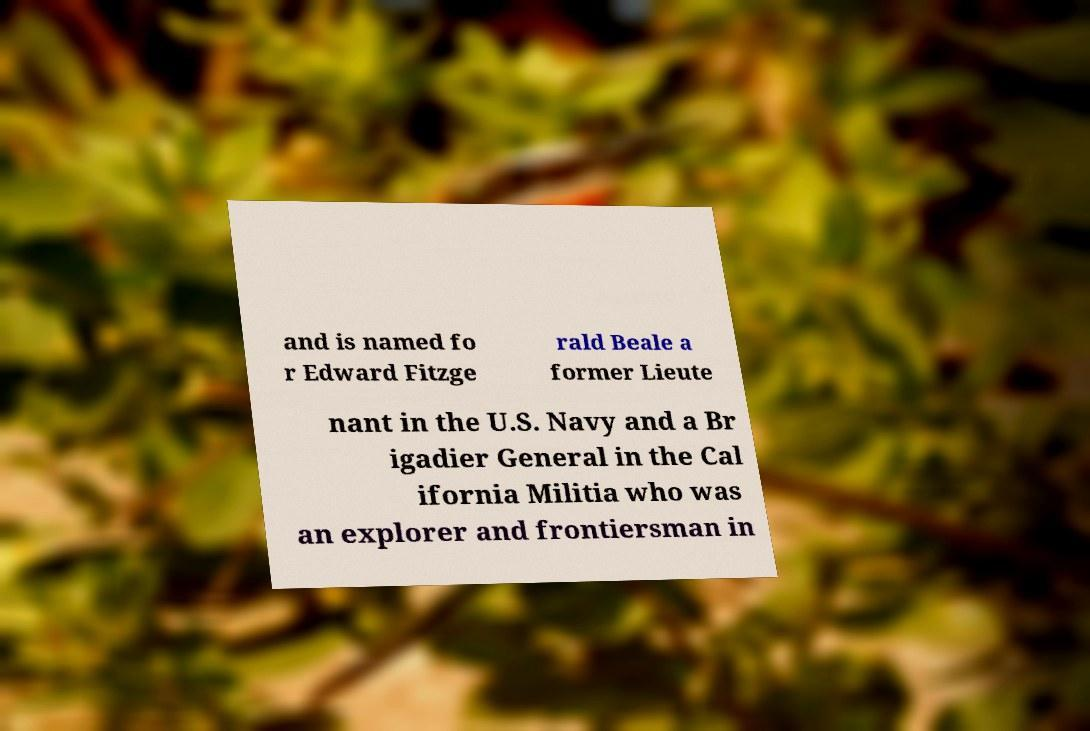Could you extract and type out the text from this image? and is named fo r Edward Fitzge rald Beale a former Lieute nant in the U.S. Navy and a Br igadier General in the Cal ifornia Militia who was an explorer and frontiersman in 